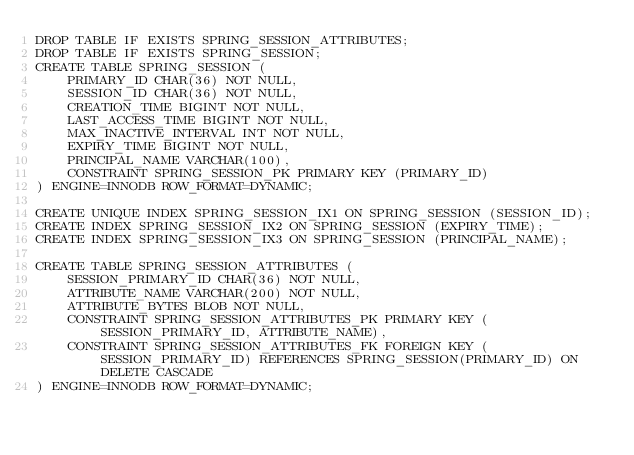<code> <loc_0><loc_0><loc_500><loc_500><_SQL_>DROP TABLE IF EXISTS SPRING_SESSION_ATTRIBUTES;
DROP TABLE IF EXISTS SPRING_SESSION;
CREATE TABLE SPRING_SESSION (
    PRIMARY_ID CHAR(36) NOT NULL,
    SESSION_ID CHAR(36) NOT NULL,
    CREATION_TIME BIGINT NOT NULL,
    LAST_ACCESS_TIME BIGINT NOT NULL,
    MAX_INACTIVE_INTERVAL INT NOT NULL,
    EXPIRY_TIME BIGINT NOT NULL,
    PRINCIPAL_NAME VARCHAR(100),
    CONSTRAINT SPRING_SESSION_PK PRIMARY KEY (PRIMARY_ID)
) ENGINE=INNODB ROW_FORMAT=DYNAMIC;

CREATE UNIQUE INDEX SPRING_SESSION_IX1 ON SPRING_SESSION (SESSION_ID);
CREATE INDEX SPRING_SESSION_IX2 ON SPRING_SESSION (EXPIRY_TIME);
CREATE INDEX SPRING_SESSION_IX3 ON SPRING_SESSION (PRINCIPAL_NAME);

CREATE TABLE SPRING_SESSION_ATTRIBUTES (
    SESSION_PRIMARY_ID CHAR(36) NOT NULL,
    ATTRIBUTE_NAME VARCHAR(200) NOT NULL,
    ATTRIBUTE_BYTES BLOB NOT NULL,
    CONSTRAINT SPRING_SESSION_ATTRIBUTES_PK PRIMARY KEY (SESSION_PRIMARY_ID, ATTRIBUTE_NAME),
    CONSTRAINT SPRING_SESSION_ATTRIBUTES_FK FOREIGN KEY (SESSION_PRIMARY_ID) REFERENCES SPRING_SESSION(PRIMARY_ID) ON DELETE CASCADE
) ENGINE=INNODB ROW_FORMAT=DYNAMIC;</code> 